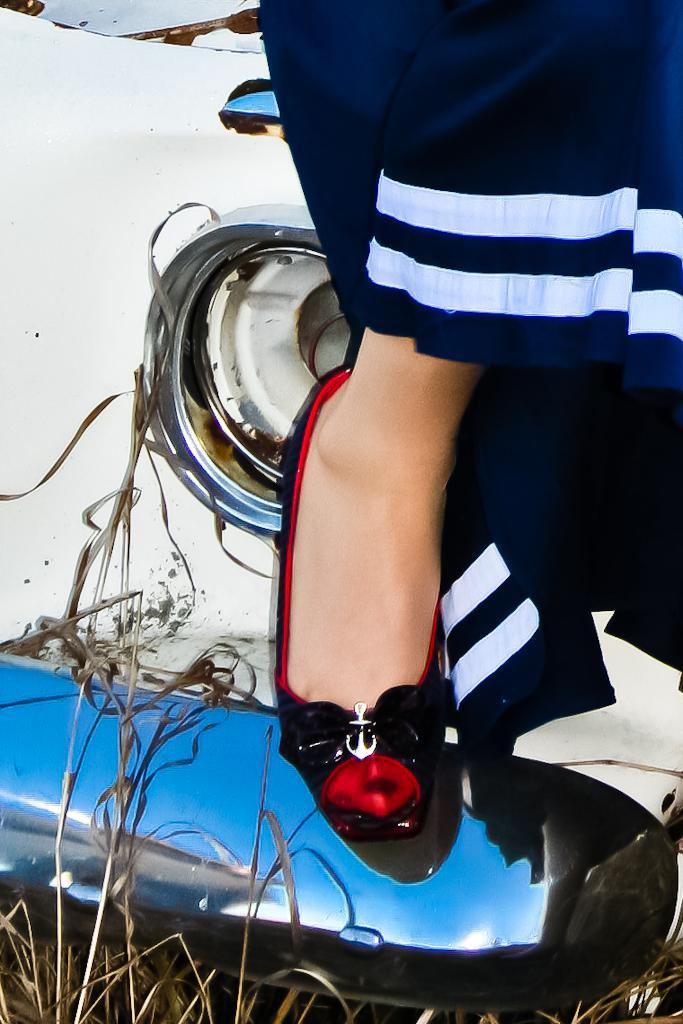Who is present in the image? There is a woman in the image. What type of footwear is the woman wearing? The woman is wearing black footwear. What is the woman doing with her leg in the image? The woman's leg is on an object. What is the color of the object the woman's leg is on? The object is white in color. What type of animal is interacting with the woman's leg on the white object? There is no animal present in the image; the woman's leg is simply on a white object. How many buckets are visible in the image? There are no buckets present in the image. 